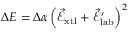Convert formula to latex. <formula><loc_0><loc_0><loc_500><loc_500>\Delta E = \Delta \alpha \left ( \vec { \mathcal { E } } _ { x t l } + \vec { \mathcal { E } } _ { l a b } ^ { \prime } \right ) ^ { 2 }</formula> 